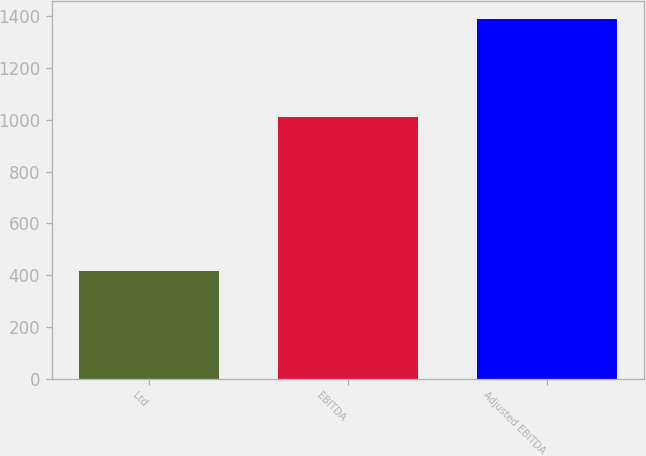<chart> <loc_0><loc_0><loc_500><loc_500><bar_chart><fcel>Ltd<fcel>EBITDA<fcel>Adjusted EBITDA<nl><fcel>416.9<fcel>1011.6<fcel>1389.9<nl></chart> 